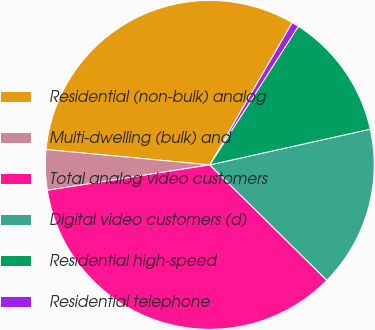<chart> <loc_0><loc_0><loc_500><loc_500><pie_chart><fcel>Residential (non-bulk) analog<fcel>Multi-dwelling (bulk) and<fcel>Total analog video customers<fcel>Digital video customers (d)<fcel>Residential high-speed<fcel>Residential telephone<nl><fcel>31.87%<fcel>3.96%<fcel>35.14%<fcel>15.87%<fcel>12.46%<fcel>0.69%<nl></chart> 